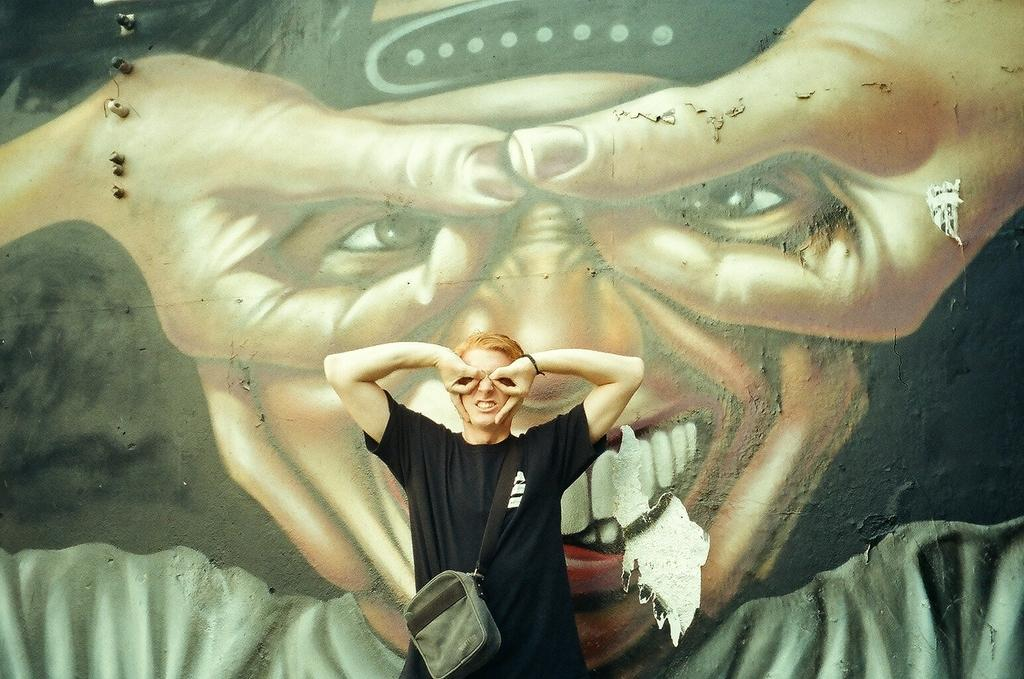Where was the image taken? The image was taken outdoors. What can be seen in the background of the image? There is a wall with a painting of a man in the background. What is the main subject of the image? A man is standing in the middle of the image. What type of music can be heard coming from the zoo in the image? There is no zoo present in the image, and therefore no music can be heard coming from it. 